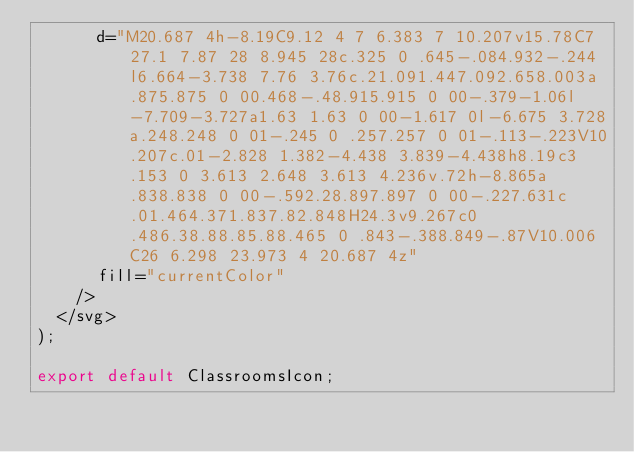<code> <loc_0><loc_0><loc_500><loc_500><_TypeScript_>      d="M20.687 4h-8.19C9.12 4 7 6.383 7 10.207v15.78C7 27.1 7.87 28 8.945 28c.325 0 .645-.084.932-.244l6.664-3.738 7.76 3.76c.21.091.447.092.658.003a.875.875 0 00.468-.48.915.915 0 00-.379-1.06l-7.709-3.727a1.63 1.63 0 00-1.617 0l-6.675 3.728a.248.248 0 01-.245 0 .257.257 0 01-.113-.223V10.207c.01-2.828 1.382-4.438 3.839-4.438h8.19c3.153 0 3.613 2.648 3.613 4.236v.72h-8.865a.838.838 0 00-.592.28.897.897 0 00-.227.631c.01.464.371.837.82.848H24.3v9.267c0 .486.38.88.85.88.465 0 .843-.388.849-.87V10.006C26 6.298 23.973 4 20.687 4z"
      fill="currentColor"
    />
  </svg>
);

export default ClassroomsIcon;
</code> 